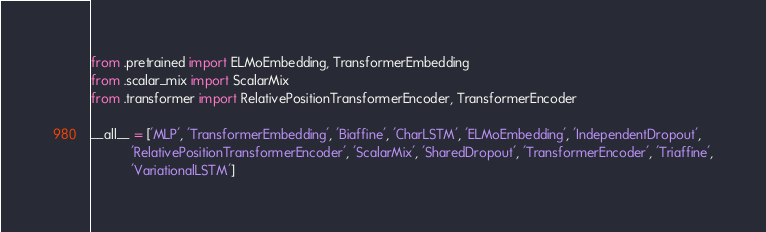<code> <loc_0><loc_0><loc_500><loc_500><_Python_>from .pretrained import ELMoEmbedding, TransformerEmbedding
from .scalar_mix import ScalarMix
from .transformer import RelativePositionTransformerEncoder, TransformerEncoder

__all__ = ['MLP', 'TransformerEmbedding', 'Biaffine', 'CharLSTM', 'ELMoEmbedding', 'IndependentDropout',
           'RelativePositionTransformerEncoder', 'ScalarMix', 'SharedDropout', 'TransformerEncoder', 'Triaffine',
           'VariationalLSTM']
</code> 